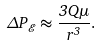Convert formula to latex. <formula><loc_0><loc_0><loc_500><loc_500>\Delta P _ { \mathcal { E } } \approx \frac { 3 Q \mu } { r ^ { 3 } } .</formula> 